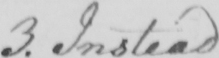Please transcribe the handwritten text in this image. 3 . Instead 